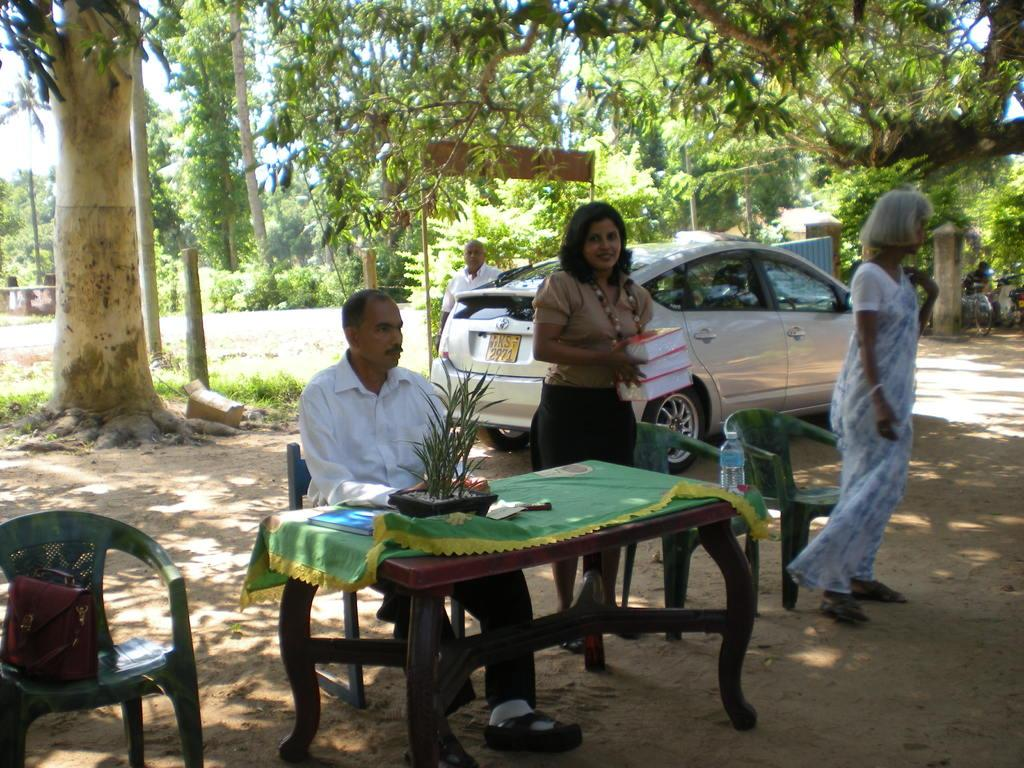Who or what can be seen in the image? There are people in the image. What object is present in the image that might be used for eating or working? There is a table in the image. What is placed on the table in the image? There is a plant on the table. What type of vehicle is visible in the image? There is a car in the image. What type of natural vegetation can be seen in the image? There are trees in the image. What type of birds can be seen flying over the car in the image? There are no birds visible in the image; it only features people, a table, a plant, a car, and trees. 